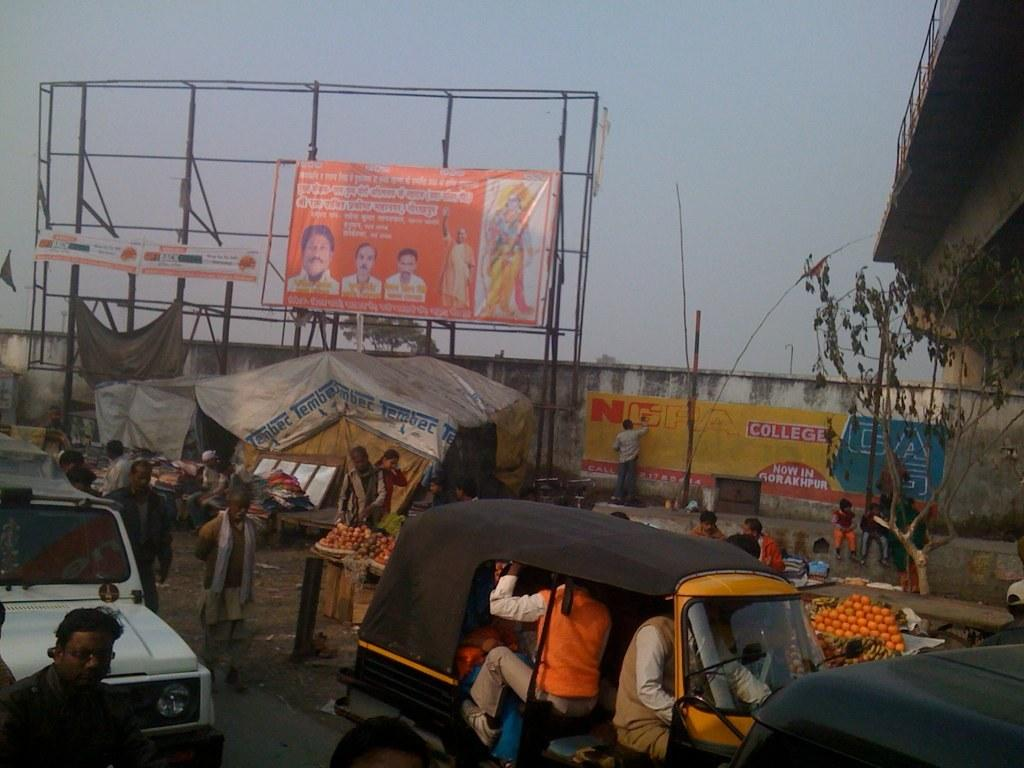<image>
Relay a brief, clear account of the picture shown. A sign for NGRA College is being painted. 